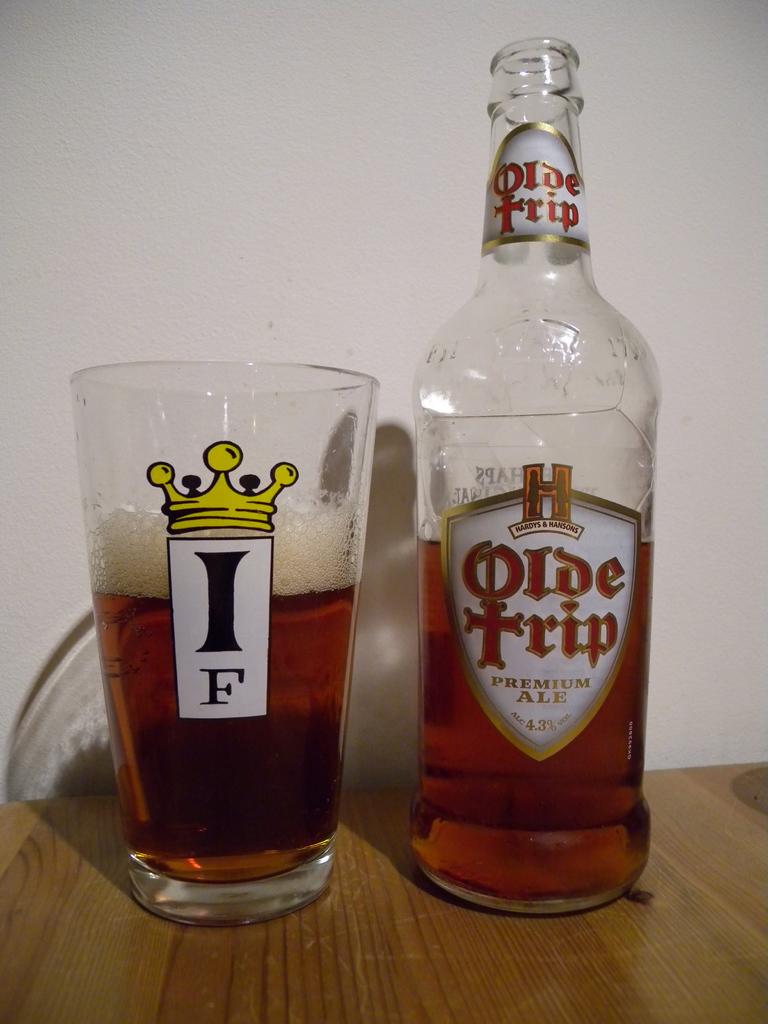What is the brand name of this alcohol?
Your answer should be compact. Olde trip. 